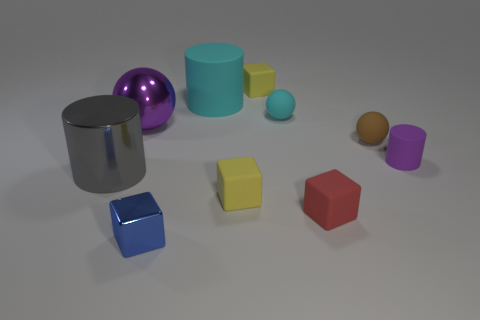The blue object that is the same size as the red rubber thing is what shape?
Provide a succinct answer. Cube. How many purple things are left of the large cylinder right of the cube in front of the red block?
Your answer should be very brief. 1. How many matte things are big cyan cylinders or tiny cubes?
Offer a very short reply. 4. There is a thing that is on the left side of the blue thing and in front of the tiny purple cylinder; what is its color?
Give a very brief answer. Gray. There is a red matte cube that is in front of the gray shiny thing; is it the same size as the tiny blue metallic thing?
Your response must be concise. Yes. What number of things are either purple objects that are on the left side of the tiny red block or tiny brown rubber balls?
Offer a very short reply. 2. Is there another blue metal ball that has the same size as the shiny ball?
Your response must be concise. No. There is a cyan thing that is the same size as the purple metallic ball; what is its material?
Keep it short and to the point. Rubber. What is the shape of the thing that is both right of the cyan matte cylinder and behind the tiny cyan matte ball?
Provide a short and direct response. Cube. What is the color of the tiny rubber ball that is on the left side of the small red rubber cube?
Ensure brevity in your answer.  Cyan. 